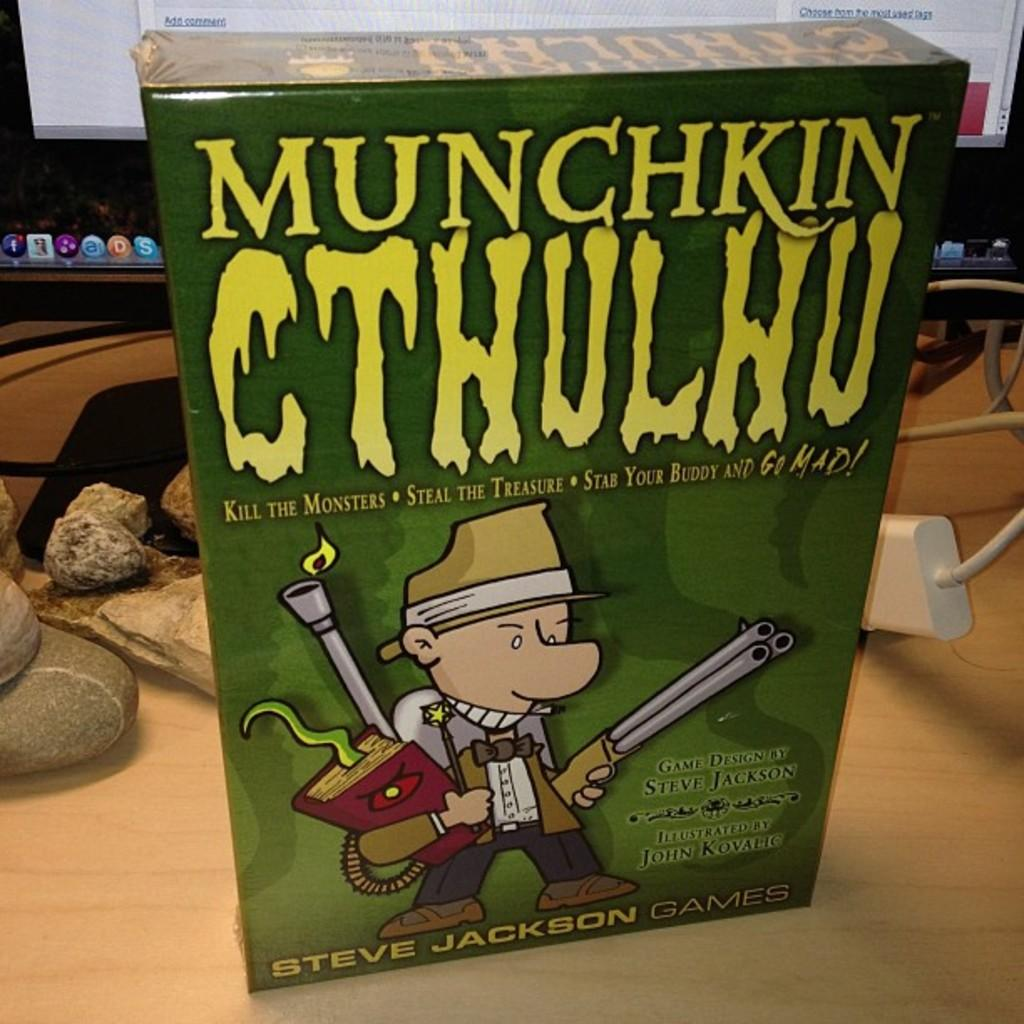<image>
Present a compact description of the photo's key features. A boxed PC game called Munchkin Cthulhu sits on a desk in front of a monitor. 